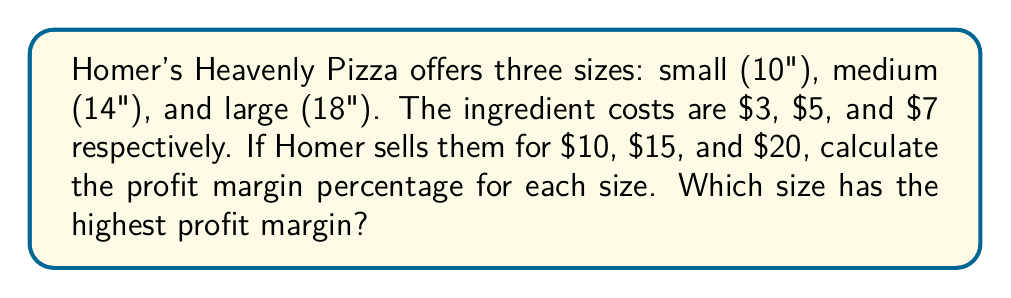What is the answer to this math problem? Let's calculate the profit margin for each size:

1. Small (10") pizza:
   - Cost: $3
   - Selling price: $10
   - Profit: $10 - $3 = $7
   - Profit margin: $\frac{\text{Profit}}{\text{Selling Price}} \times 100\%$
   $$\frac{7}{10} \times 100\% = 70\%$$

2. Medium (14") pizza:
   - Cost: $5
   - Selling price: $15
   - Profit: $15 - $5 = $10
   - Profit margin: $\frac{\text{Profit}}{\text{Selling Price}} \times 100\%$
   $$\frac{10}{15} \times 100\% = 66.67\%$$

3. Large (18") pizza:
   - Cost: $7
   - Selling price: $20
   - Profit: $20 - $7 = $13
   - Profit margin: $\frac{\text{Profit}}{\text{Selling Price}} \times 100\%$
   $$\frac{13}{20} \times 100\% = 65\%$$

Comparing the profit margins:
Small: 70%
Medium: 66.67%
Large: 65%

The small (10") pizza has the highest profit margin at 70%.
Answer: Small (10") pizza; 70% 